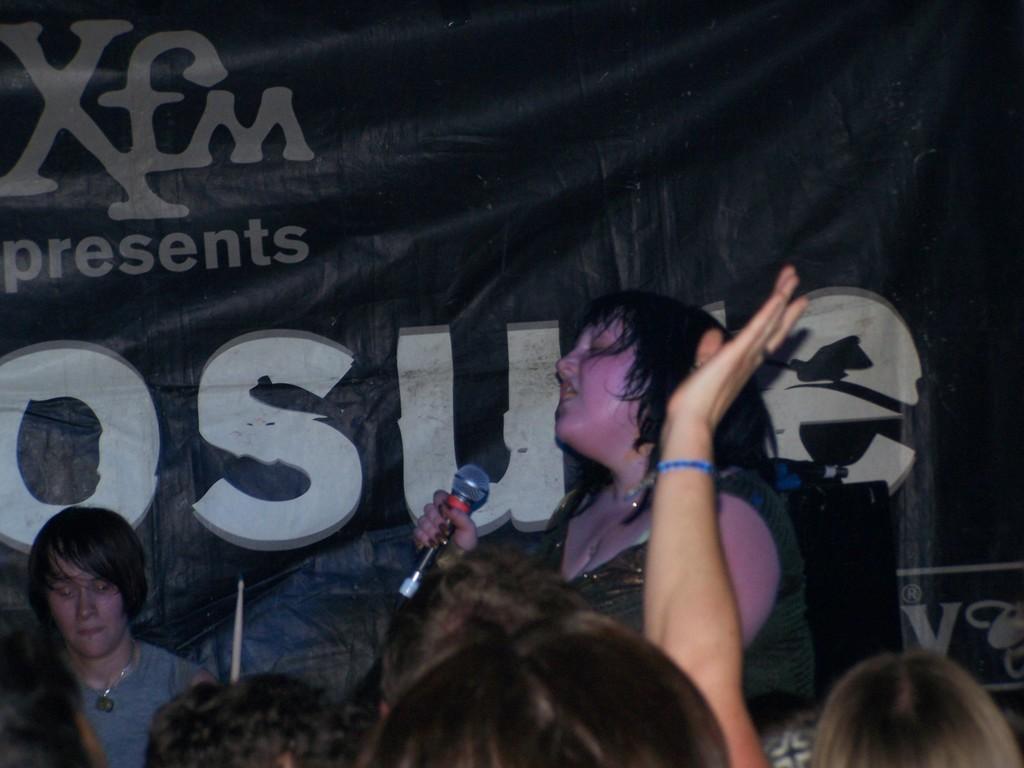Could you give a brief overview of what you see in this image? In the image we can see there is a woman standing and she is holding a mic in her hand, there is a person standing at the back. In front there are spectators watching the woman and behind there is a banner. 